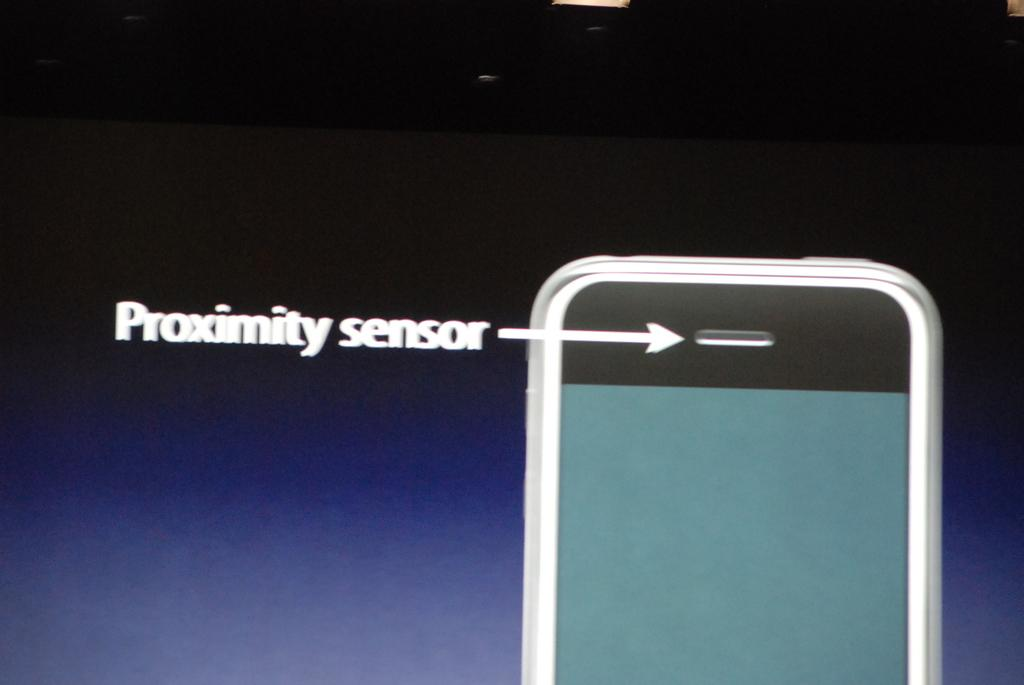<image>
Present a compact description of the photo's key features. The proximity sensor of a smart phone is pointed out. 